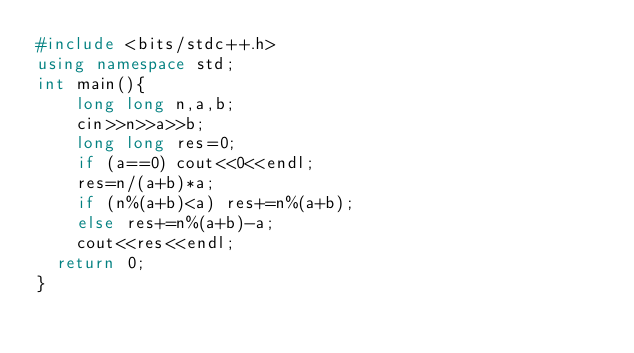<code> <loc_0><loc_0><loc_500><loc_500><_C++_>#include <bits/stdc++.h>
using namespace std;
int main(){
    long long n,a,b;
    cin>>n>>a>>b;
    long long res=0;
    if (a==0) cout<<0<<endl;
    res=n/(a+b)*a;
    if (n%(a+b)<a) res+=n%(a+b);
    else res+=n%(a+b)-a;
    cout<<res<<endl;
	return 0;
}</code> 